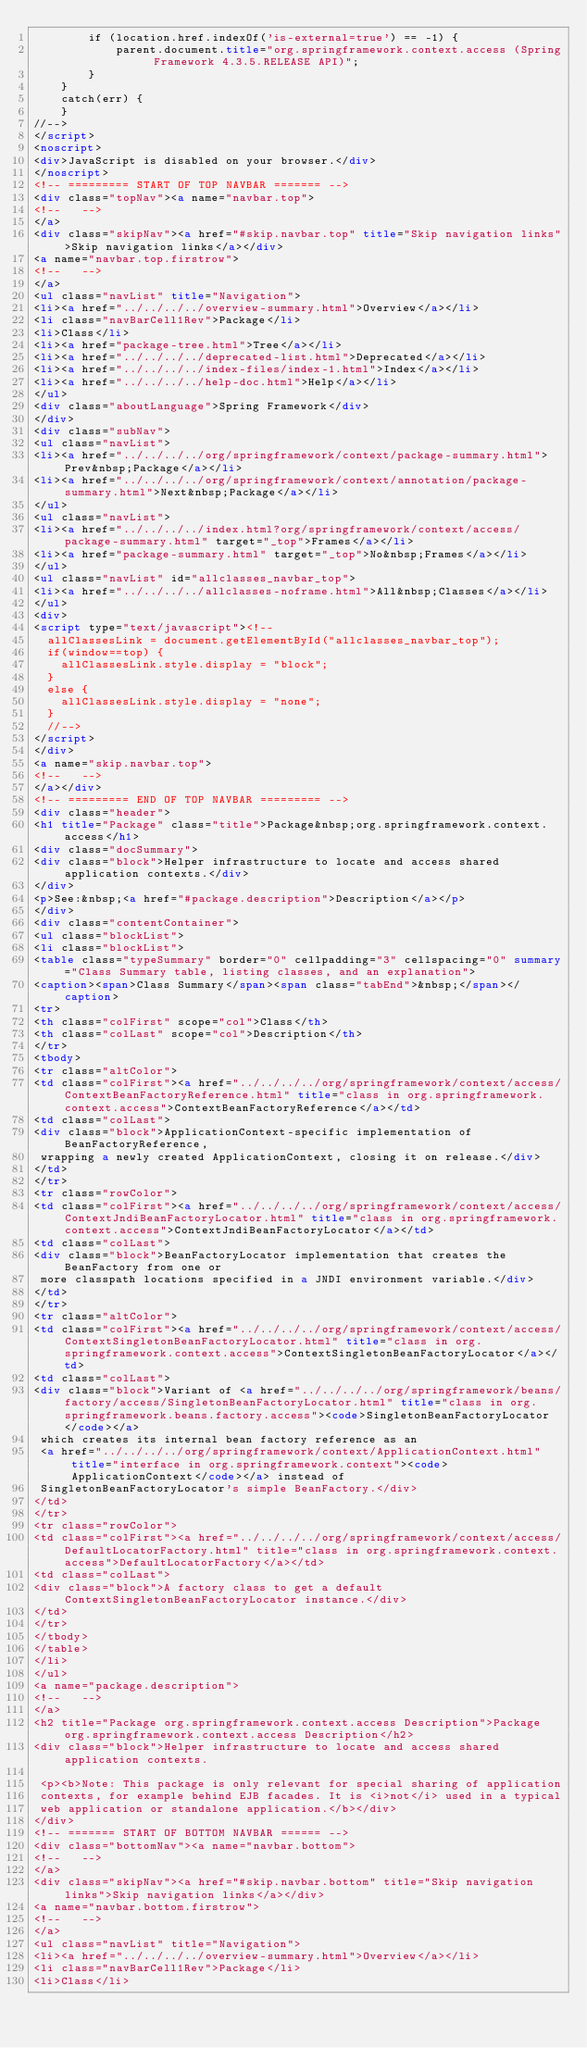<code> <loc_0><loc_0><loc_500><loc_500><_HTML_>        if (location.href.indexOf('is-external=true') == -1) {
            parent.document.title="org.springframework.context.access (Spring Framework 4.3.5.RELEASE API)";
        }
    }
    catch(err) {
    }
//-->
</script>
<noscript>
<div>JavaScript is disabled on your browser.</div>
</noscript>
<!-- ========= START OF TOP NAVBAR ======= -->
<div class="topNav"><a name="navbar.top">
<!--   -->
</a>
<div class="skipNav"><a href="#skip.navbar.top" title="Skip navigation links">Skip navigation links</a></div>
<a name="navbar.top.firstrow">
<!--   -->
</a>
<ul class="navList" title="Navigation">
<li><a href="../../../../overview-summary.html">Overview</a></li>
<li class="navBarCell1Rev">Package</li>
<li>Class</li>
<li><a href="package-tree.html">Tree</a></li>
<li><a href="../../../../deprecated-list.html">Deprecated</a></li>
<li><a href="../../../../index-files/index-1.html">Index</a></li>
<li><a href="../../../../help-doc.html">Help</a></li>
</ul>
<div class="aboutLanguage">Spring Framework</div>
</div>
<div class="subNav">
<ul class="navList">
<li><a href="../../../../org/springframework/context/package-summary.html">Prev&nbsp;Package</a></li>
<li><a href="../../../../org/springframework/context/annotation/package-summary.html">Next&nbsp;Package</a></li>
</ul>
<ul class="navList">
<li><a href="../../../../index.html?org/springframework/context/access/package-summary.html" target="_top">Frames</a></li>
<li><a href="package-summary.html" target="_top">No&nbsp;Frames</a></li>
</ul>
<ul class="navList" id="allclasses_navbar_top">
<li><a href="../../../../allclasses-noframe.html">All&nbsp;Classes</a></li>
</ul>
<div>
<script type="text/javascript"><!--
  allClassesLink = document.getElementById("allclasses_navbar_top");
  if(window==top) {
    allClassesLink.style.display = "block";
  }
  else {
    allClassesLink.style.display = "none";
  }
  //-->
</script>
</div>
<a name="skip.navbar.top">
<!--   -->
</a></div>
<!-- ========= END OF TOP NAVBAR ========= -->
<div class="header">
<h1 title="Package" class="title">Package&nbsp;org.springframework.context.access</h1>
<div class="docSummary">
<div class="block">Helper infrastructure to locate and access shared application contexts.</div>
</div>
<p>See:&nbsp;<a href="#package.description">Description</a></p>
</div>
<div class="contentContainer">
<ul class="blockList">
<li class="blockList">
<table class="typeSummary" border="0" cellpadding="3" cellspacing="0" summary="Class Summary table, listing classes, and an explanation">
<caption><span>Class Summary</span><span class="tabEnd">&nbsp;</span></caption>
<tr>
<th class="colFirst" scope="col">Class</th>
<th class="colLast" scope="col">Description</th>
</tr>
<tbody>
<tr class="altColor">
<td class="colFirst"><a href="../../../../org/springframework/context/access/ContextBeanFactoryReference.html" title="class in org.springframework.context.access">ContextBeanFactoryReference</a></td>
<td class="colLast">
<div class="block">ApplicationContext-specific implementation of BeanFactoryReference,
 wrapping a newly created ApplicationContext, closing it on release.</div>
</td>
</tr>
<tr class="rowColor">
<td class="colFirst"><a href="../../../../org/springframework/context/access/ContextJndiBeanFactoryLocator.html" title="class in org.springframework.context.access">ContextJndiBeanFactoryLocator</a></td>
<td class="colLast">
<div class="block">BeanFactoryLocator implementation that creates the BeanFactory from one or
 more classpath locations specified in a JNDI environment variable.</div>
</td>
</tr>
<tr class="altColor">
<td class="colFirst"><a href="../../../../org/springframework/context/access/ContextSingletonBeanFactoryLocator.html" title="class in org.springframework.context.access">ContextSingletonBeanFactoryLocator</a></td>
<td class="colLast">
<div class="block">Variant of <a href="../../../../org/springframework/beans/factory/access/SingletonBeanFactoryLocator.html" title="class in org.springframework.beans.factory.access"><code>SingletonBeanFactoryLocator</code></a>
 which creates its internal bean factory reference as an
 <a href="../../../../org/springframework/context/ApplicationContext.html" title="interface in org.springframework.context"><code>ApplicationContext</code></a> instead of
 SingletonBeanFactoryLocator's simple BeanFactory.</div>
</td>
</tr>
<tr class="rowColor">
<td class="colFirst"><a href="../../../../org/springframework/context/access/DefaultLocatorFactory.html" title="class in org.springframework.context.access">DefaultLocatorFactory</a></td>
<td class="colLast">
<div class="block">A factory class to get a default ContextSingletonBeanFactoryLocator instance.</div>
</td>
</tr>
</tbody>
</table>
</li>
</ul>
<a name="package.description">
<!--   -->
</a>
<h2 title="Package org.springframework.context.access Description">Package org.springframework.context.access Description</h2>
<div class="block">Helper infrastructure to locate and access shared application contexts.

 <p><b>Note: This package is only relevant for special sharing of application
 contexts, for example behind EJB facades. It is <i>not</i> used in a typical
 web application or standalone application.</b></div>
</div>
<!-- ======= START OF BOTTOM NAVBAR ====== -->
<div class="bottomNav"><a name="navbar.bottom">
<!--   -->
</a>
<div class="skipNav"><a href="#skip.navbar.bottom" title="Skip navigation links">Skip navigation links</a></div>
<a name="navbar.bottom.firstrow">
<!--   -->
</a>
<ul class="navList" title="Navigation">
<li><a href="../../../../overview-summary.html">Overview</a></li>
<li class="navBarCell1Rev">Package</li>
<li>Class</li></code> 